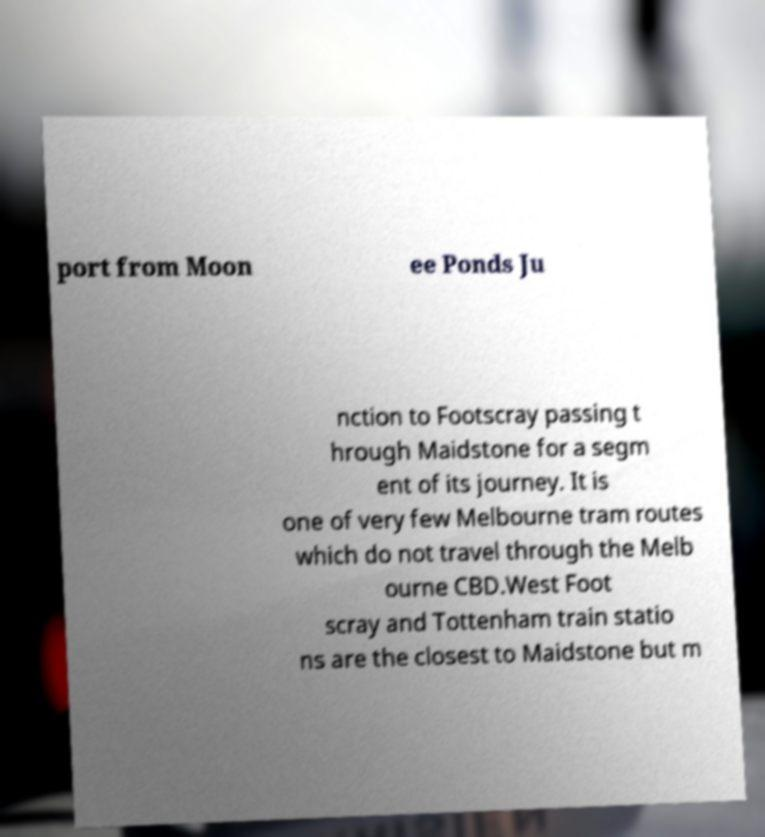I need the written content from this picture converted into text. Can you do that? port from Moon ee Ponds Ju nction to Footscray passing t hrough Maidstone for a segm ent of its journey. It is one of very few Melbourne tram routes which do not travel through the Melb ourne CBD.West Foot scray and Tottenham train statio ns are the closest to Maidstone but m 